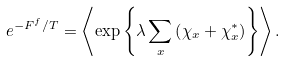Convert formula to latex. <formula><loc_0><loc_0><loc_500><loc_500>e ^ { - F ^ { f } / T } = \left \langle \exp \left \{ \lambda \sum _ { x } \left ( \chi _ { x } + \chi _ { x } ^ { \ast } \right ) \right \} \right \rangle .</formula> 